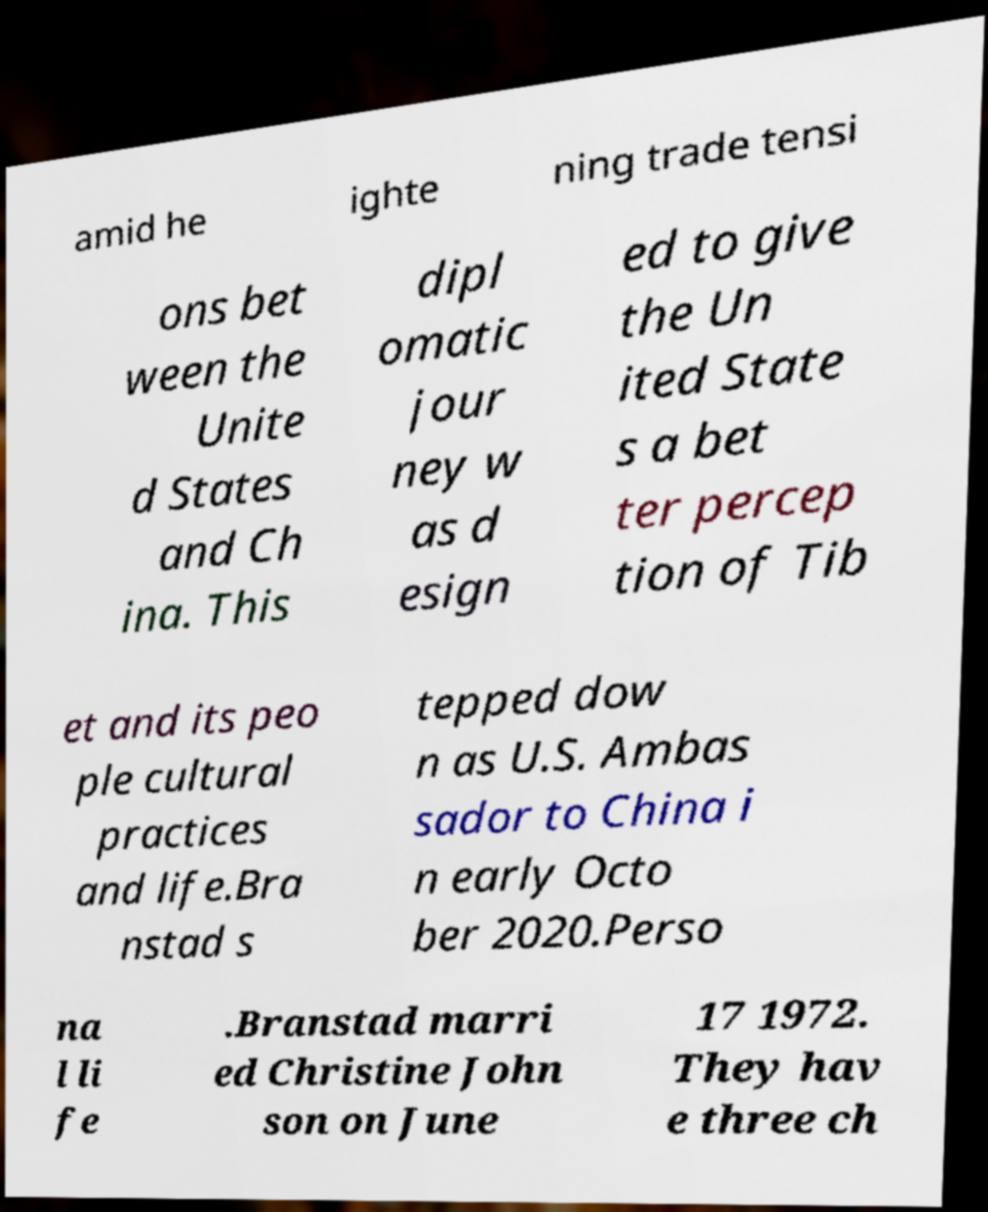For documentation purposes, I need the text within this image transcribed. Could you provide that? amid he ighte ning trade tensi ons bet ween the Unite d States and Ch ina. This dipl omatic jour ney w as d esign ed to give the Un ited State s a bet ter percep tion of Tib et and its peo ple cultural practices and life.Bra nstad s tepped dow n as U.S. Ambas sador to China i n early Octo ber 2020.Perso na l li fe .Branstad marri ed Christine John son on June 17 1972. They hav e three ch 